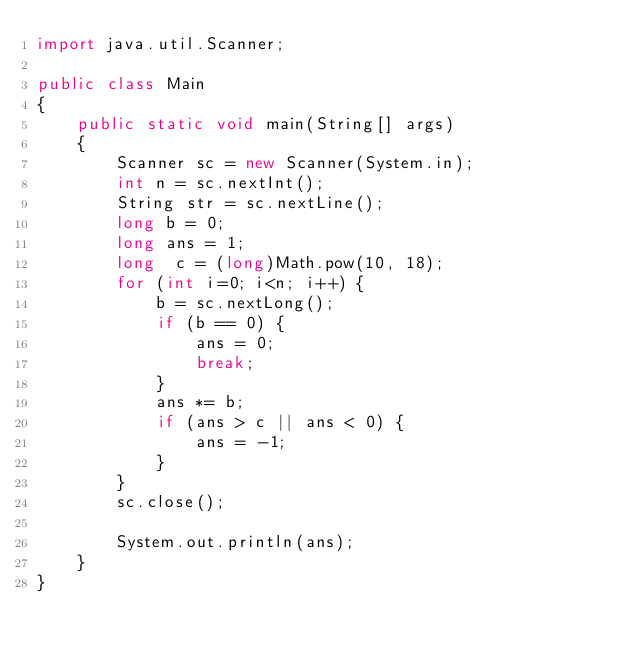<code> <loc_0><loc_0><loc_500><loc_500><_Java_>import java.util.Scanner;

public class Main
{
	public static void main(String[] args)
	{
		Scanner sc = new Scanner(System.in);
		int n = sc.nextInt();
		String str = sc.nextLine();
		long b = 0;
		long ans = 1;
		long  c = (long)Math.pow(10, 18);
		for (int i=0; i<n; i++) {
			b = sc.nextLong();
			if (b == 0) {
				ans = 0;
				break;
			}
			ans *= b;
			if (ans > c || ans < 0) {
				ans = -1;
			}
		}
		sc.close();

		System.out.println(ans);
	}
}
</code> 